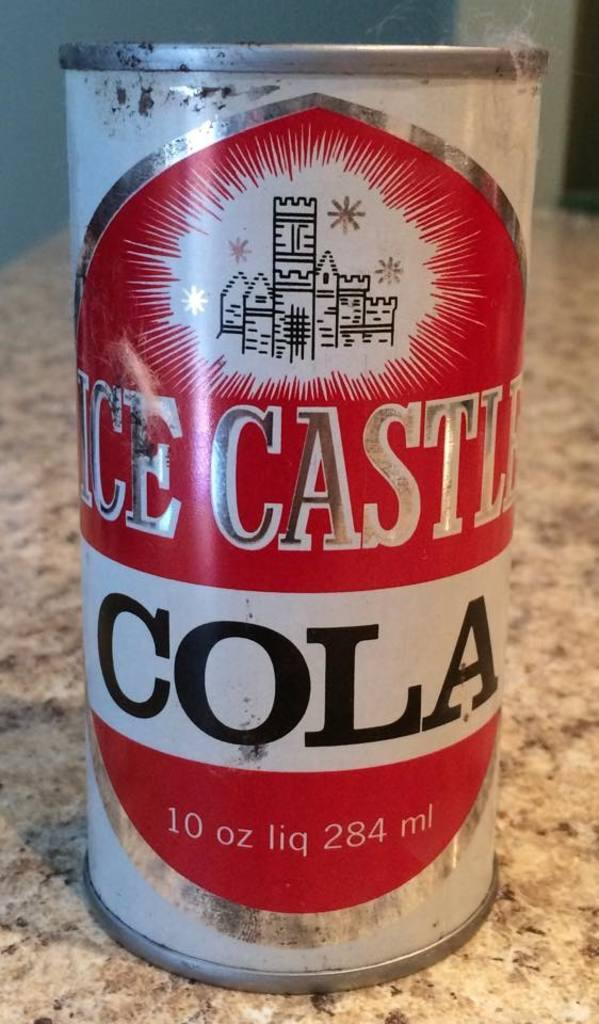<image>
Provide a brief description of the given image. A ten ounce can of Ice Castle cola. 